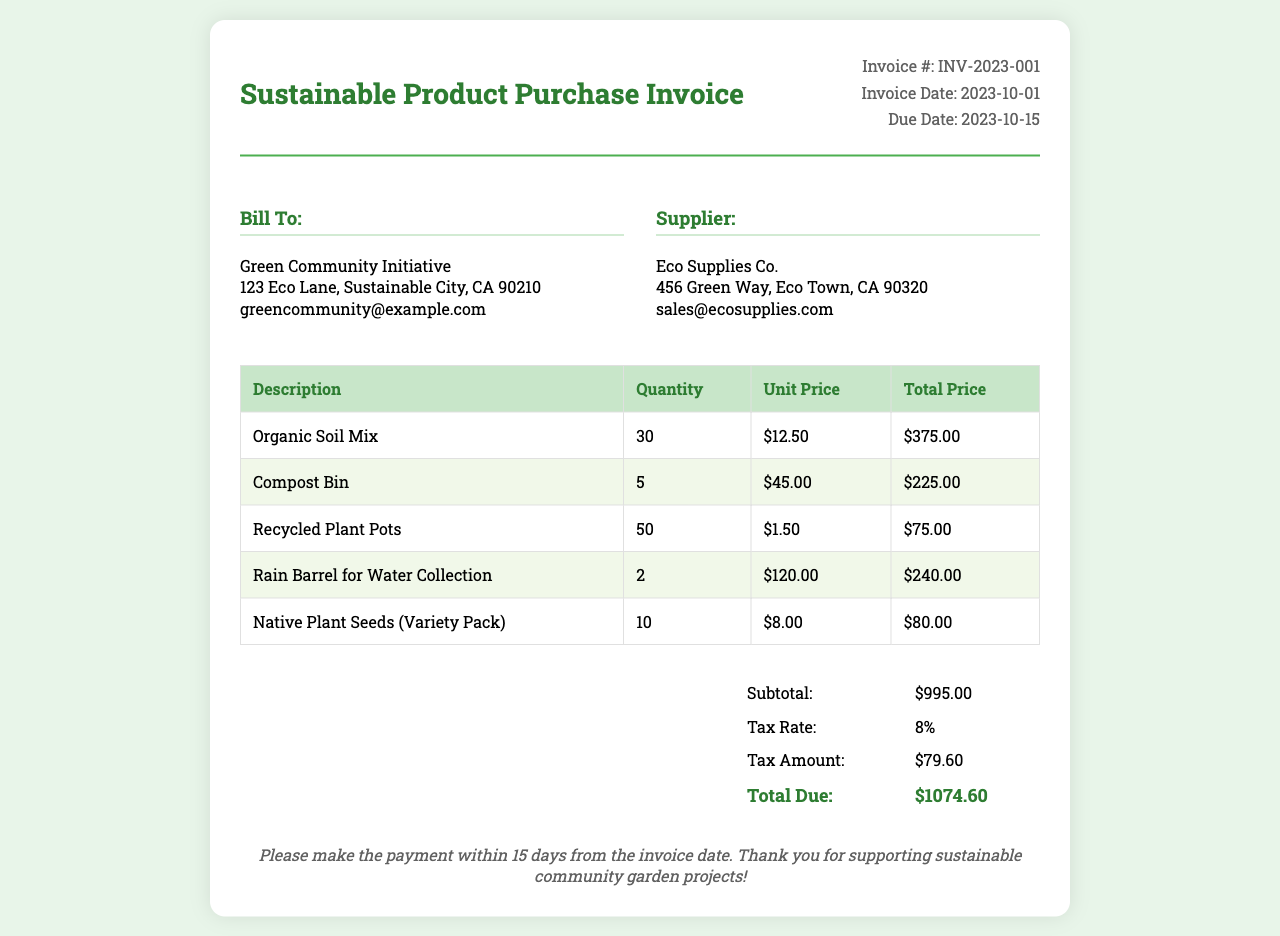What is the invoice number? The invoice number is listed under "Invoice #:" in the document.
Answer: INV-2023-001 What is the total due amount? The total due amount is shown as "Total Due:" in the total section of the invoice.
Answer: $1074.60 Who is the supplier? The supplier's information is found under the "Supplier:" section.
Answer: Eco Supplies Co What is the due date for payment? The due date can be found next to "Due Date:" in the invoice details.
Answer: 2023-10-15 How many organic soil mix units were purchased? The quantity of organic soil mix is stated in the items table under Quantity.
Answer: 30 What is the tax rate applied? The tax rate is presented in the total section as "Tax Rate:".
Answer: 8% What item has the highest unit price? The item with the highest unit price can be determined from the items table.
Answer: Rain Barrel for Water Collection What is the subtotal before tax? The subtotal is indicated as "Subtotal:" in the total section.
Answer: $995.00 What is the email address for the supplier? The supplier's email address is provided below the supplier's name.
Answer: sales@ecosupplies.com 